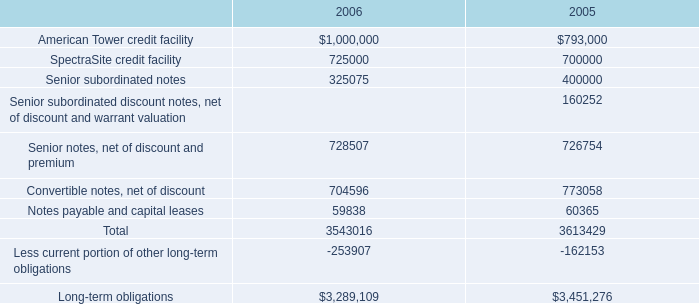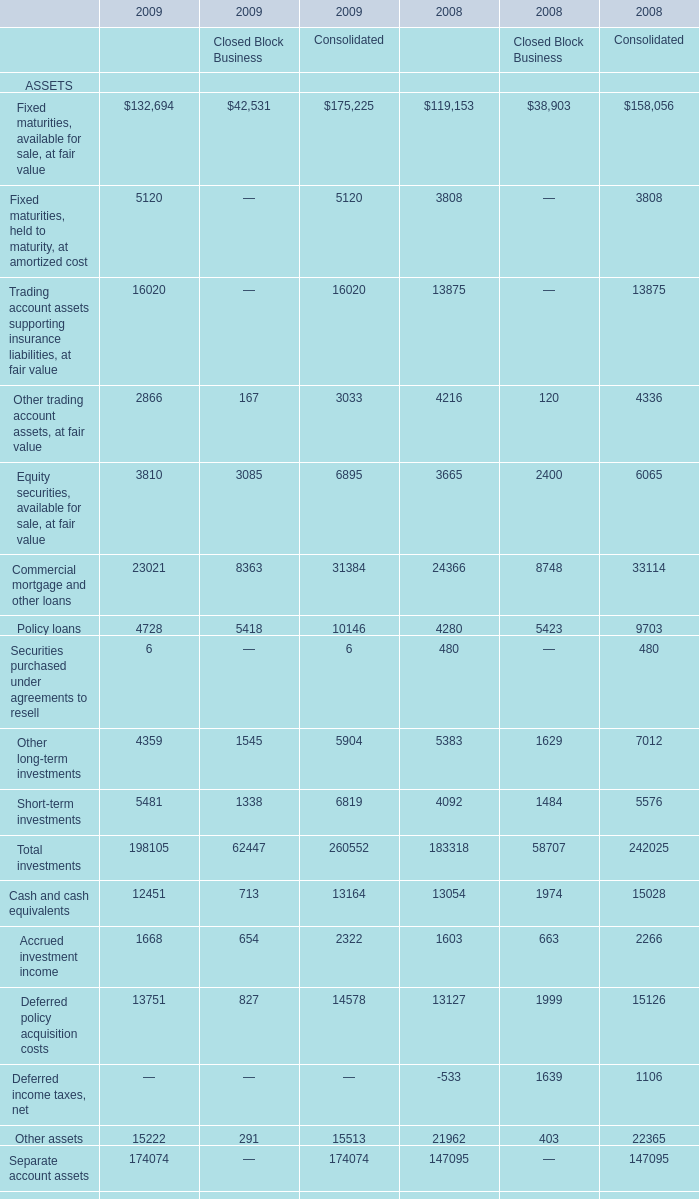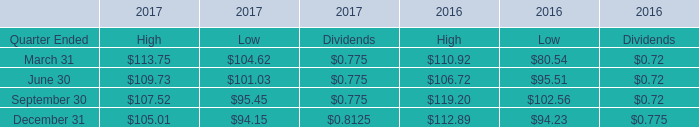When is Fixed maturities, available for sale, at fair value for Financial Services Businessthe largest? 
Answer: 2009. 